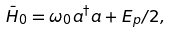Convert formula to latex. <formula><loc_0><loc_0><loc_500><loc_500>\bar { H } _ { 0 } = \omega _ { 0 } a ^ { \dag } a + E _ { p } / 2 ,</formula> 